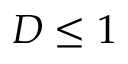Convert formula to latex. <formula><loc_0><loc_0><loc_500><loc_500>D \leq 1</formula> 